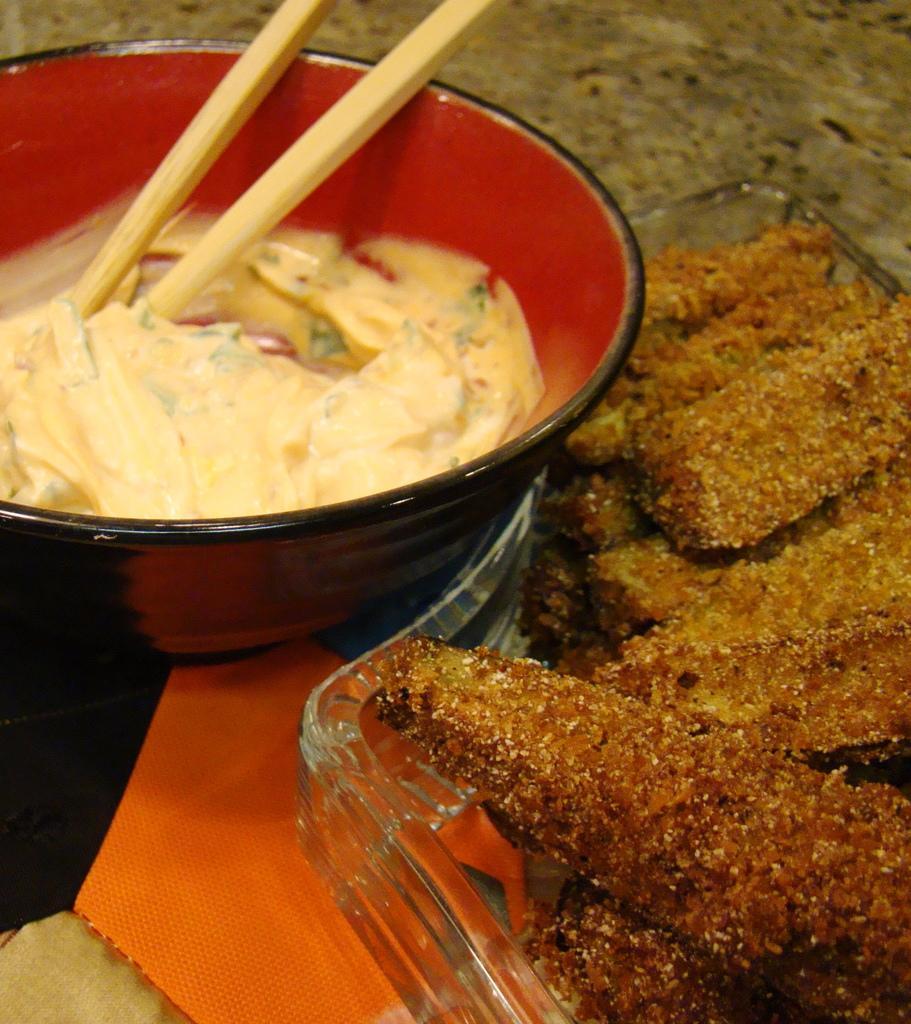How would you summarize this image in a sentence or two? There is food in a bowl with chopsticks in it. Beside it there is a plate in which food is there. 